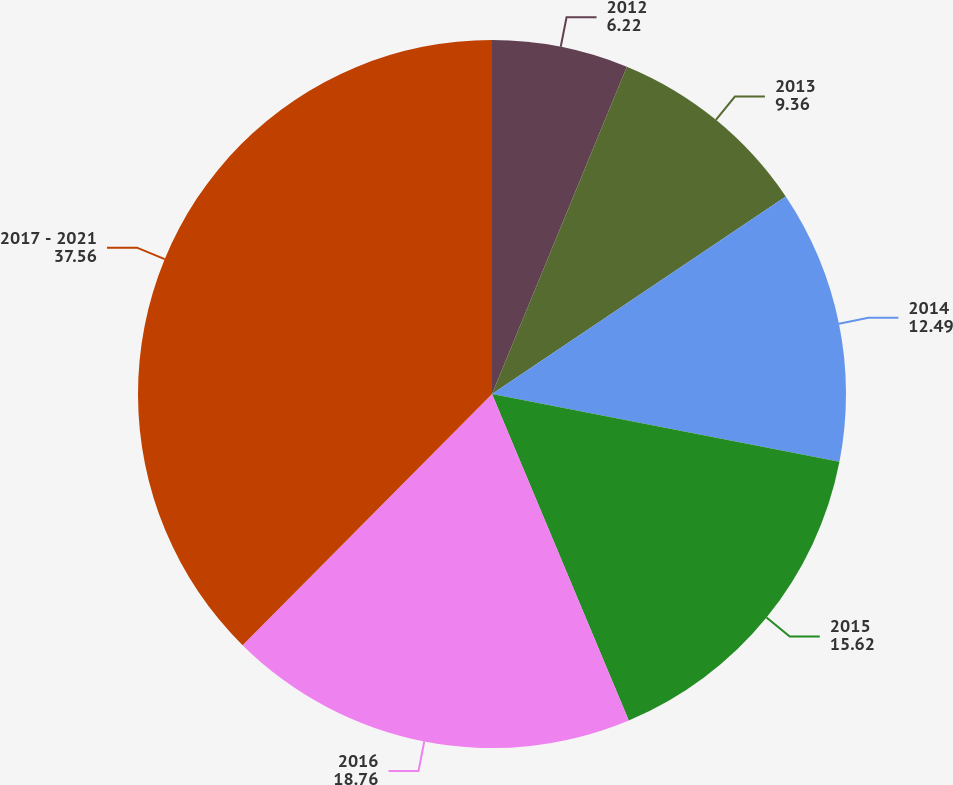<chart> <loc_0><loc_0><loc_500><loc_500><pie_chart><fcel>2012<fcel>2013<fcel>2014<fcel>2015<fcel>2016<fcel>2017 - 2021<nl><fcel>6.22%<fcel>9.36%<fcel>12.49%<fcel>15.62%<fcel>18.76%<fcel>37.56%<nl></chart> 